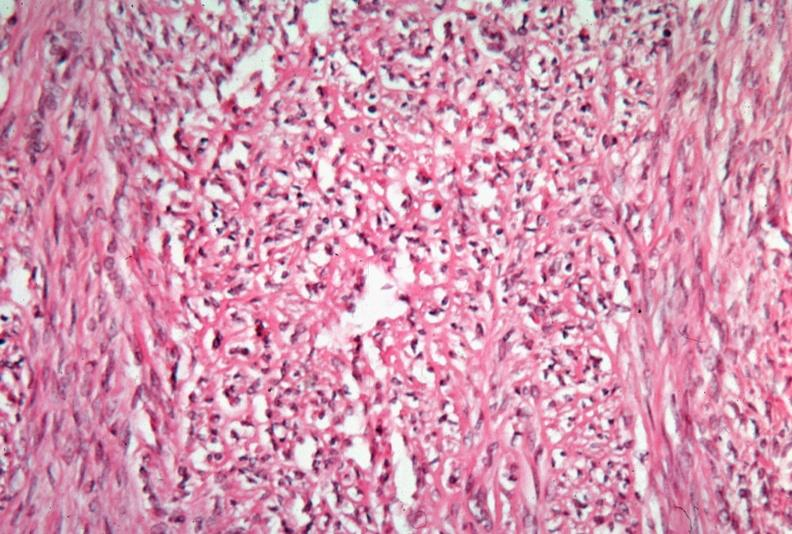s inflamed exocervix present?
Answer the question using a single word or phrase. No 